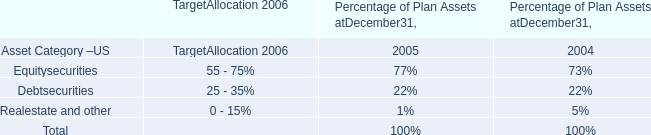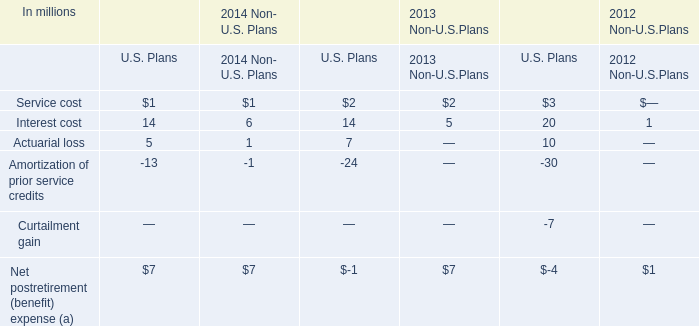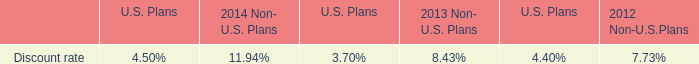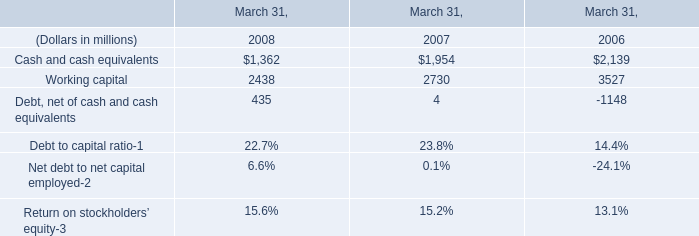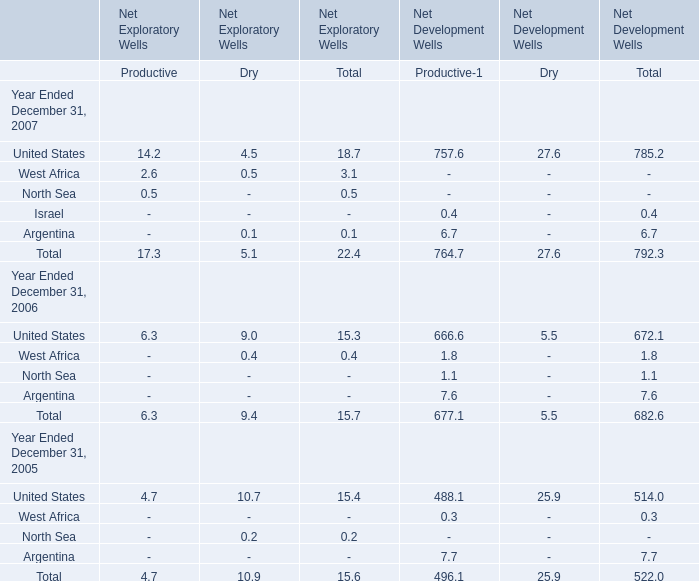What is the average amount of the total Net Exploratory Wells between Productive and Dry in 2007? 
Computations: ((17.3 + 5.1) / 2)
Answer: 11.2. 